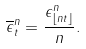<formula> <loc_0><loc_0><loc_500><loc_500>\overline { \epsilon } ^ { n } _ { t } = \frac { \epsilon ^ { n } _ { \lfloor n t \rfloor } } { n } .</formula> 